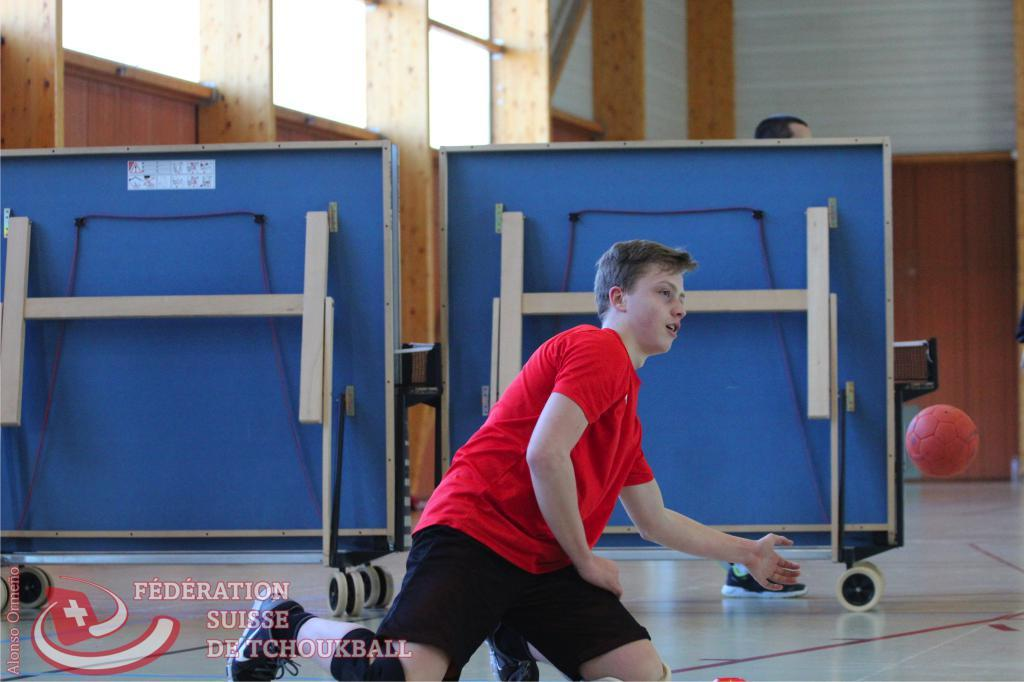<image>
Present a compact description of the photo's key features. Federation Suisse De Tchoukball reads the caption of this photo. 